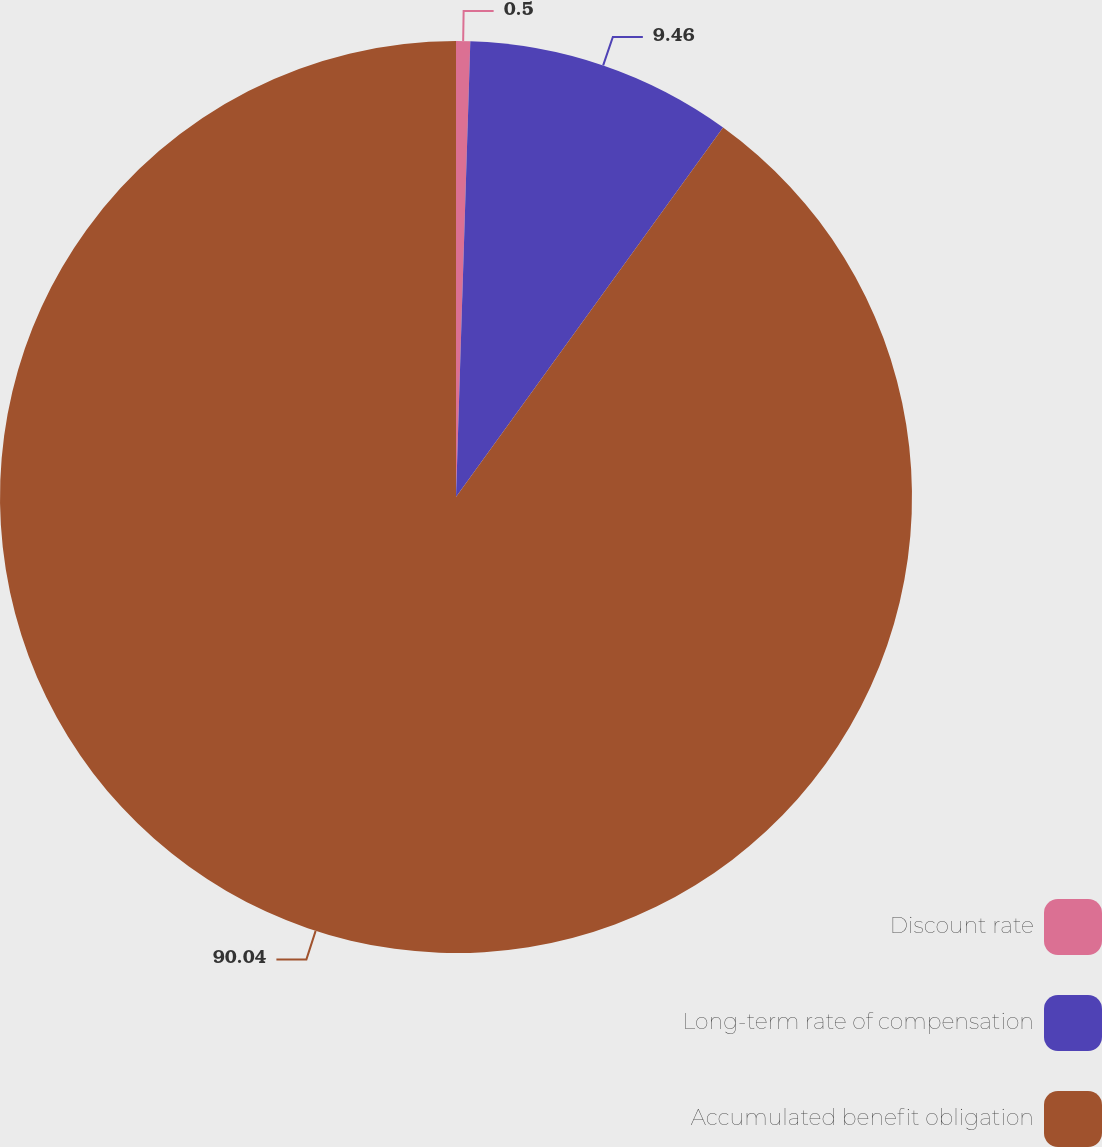Convert chart. <chart><loc_0><loc_0><loc_500><loc_500><pie_chart><fcel>Discount rate<fcel>Long-term rate of compensation<fcel>Accumulated benefit obligation<nl><fcel>0.5%<fcel>9.46%<fcel>90.04%<nl></chart> 